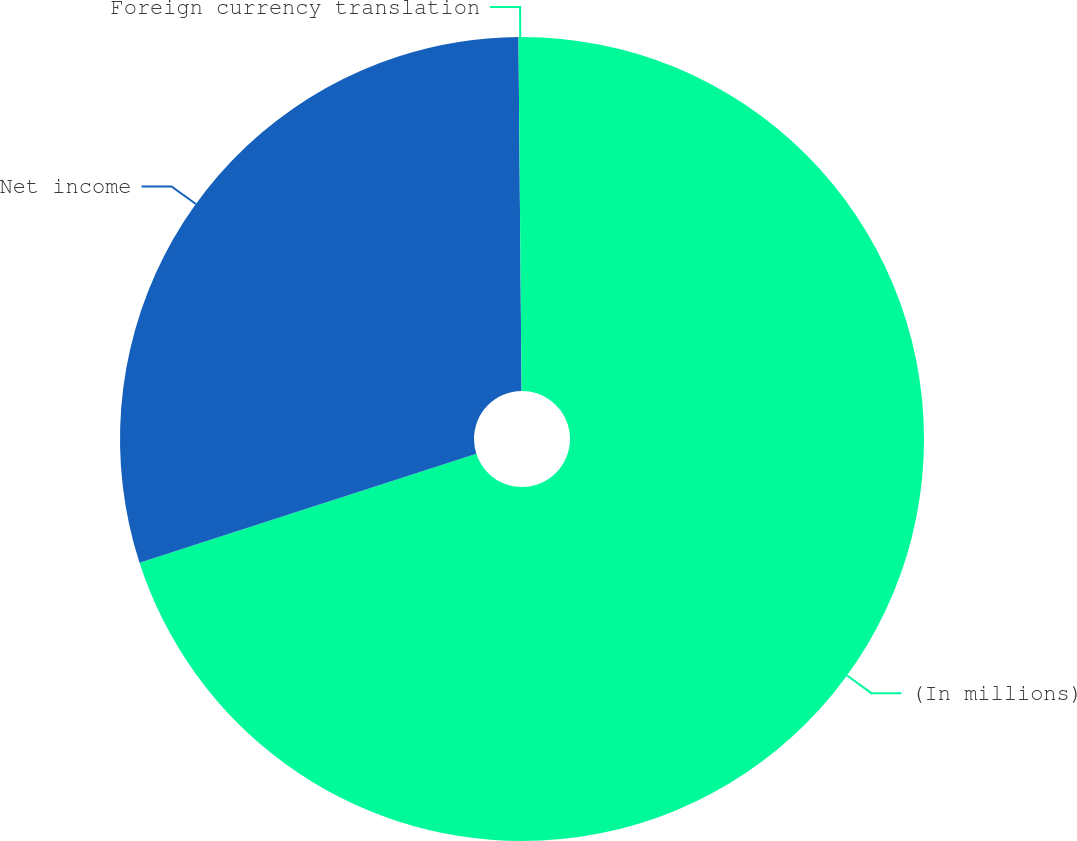Convert chart to OTSL. <chart><loc_0><loc_0><loc_500><loc_500><pie_chart><fcel>(In millions)<fcel>Net income<fcel>Foreign currency translation<nl><fcel>70.02%<fcel>29.84%<fcel>0.14%<nl></chart> 